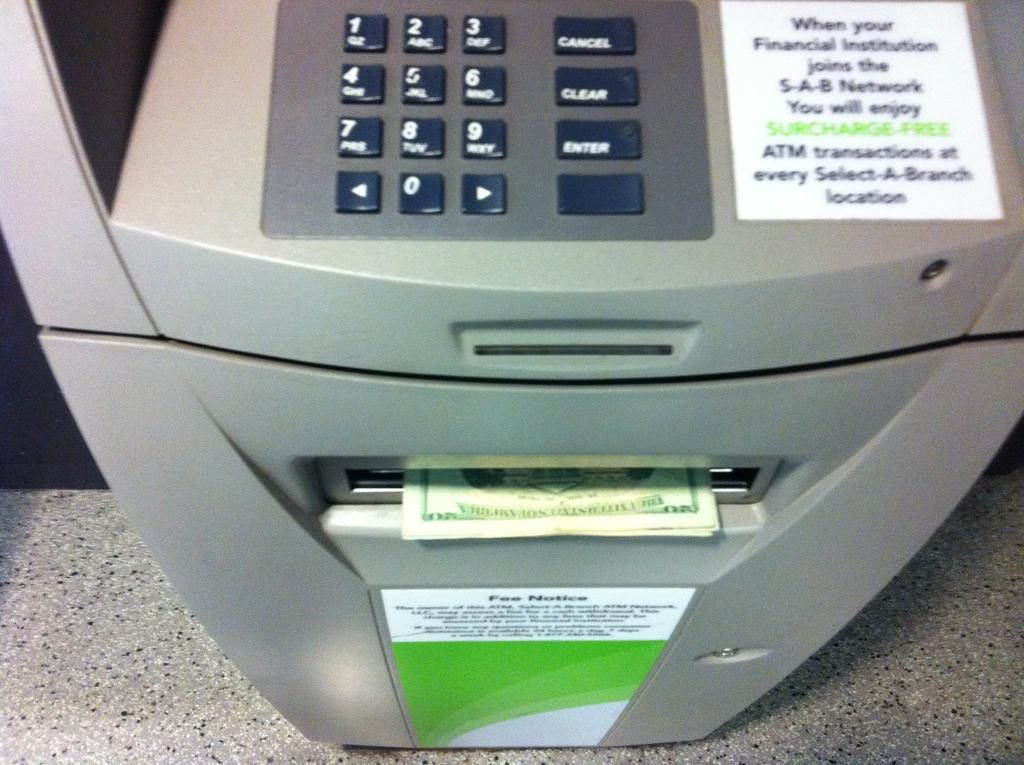<image>
Render a clear and concise summary of the photo. A grey ATM has cash coming out of it and says Surcharge-Free. 